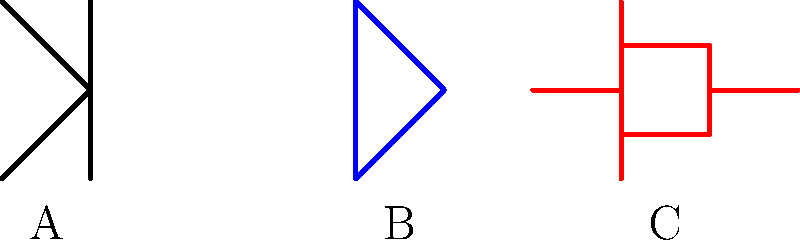As an academic publishing professional reviewing AI research papers on semiconductor devices, you encounter a figure with three schematic symbols labeled A, B, and C. Identify these symbols and explain their significance in modern electronic circuits. To identify the semiconductor devices from their schematic symbols, let's analyze each one:

1. Symbol A:
   - This is an NPN bipolar junction transistor (BJT).
   - It has three terminals: emitter (arrow pointing out), base (middle line), and collector.
   - BJTs are current-controlled devices used for amplification and switching.

2. Symbol B:
   - This represents a diode.
   - It has two terminals: anode (flat side) and cathode (line).
   - Diodes allow current flow in one direction and are used for rectification and protection.

3. Symbol C:
   - This is an N-channel MOSFET (Metal-Oxide-Semiconductor Field-Effect Transistor).
   - It has three terminals: source (top), gate (left side), and drain (bottom).
   - MOSFETs are voltage-controlled devices used in modern digital and analog circuits.

These devices are significant in modern electronic circuits for the following reasons:

1. BJTs are used in analog circuits for amplification and in digital circuits as switches.
2. Diodes are essential for rectification in power supplies and signal processing.
3. MOSFETs are the building blocks of modern digital circuits, including microprocessors and memory devices, due to their low power consumption and high integration density.

Understanding these symbols is crucial for interpreting and evaluating research papers on semiconductor devices and their applications in AI hardware.
Answer: A: NPN Transistor, B: Diode, C: N-channel MOSFET 